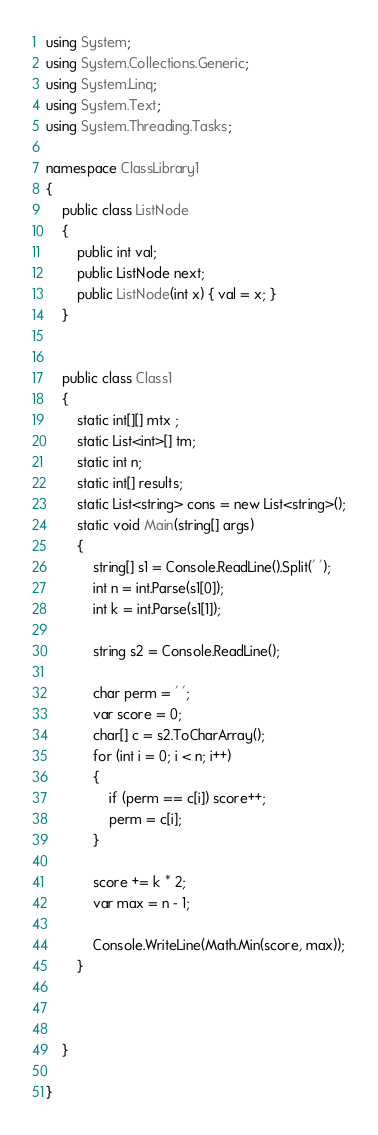<code> <loc_0><loc_0><loc_500><loc_500><_C#_>using System;
using System.Collections.Generic;
using System.Linq;
using System.Text;
using System.Threading.Tasks;

namespace ClassLibrary1
{
    public class ListNode
    {
        public int val;
        public ListNode next;
        public ListNode(int x) { val = x; }
    }


    public class Class1
    {
        static int[][] mtx ;
        static List<int>[] tm;
        static int n;
        static int[] results;
        static List<string> cons = new List<string>();
        static void Main(string[] args)
        {
            string[] s1 = Console.ReadLine().Split(' ');
            int n = int.Parse(s1[0]);
            int k = int.Parse(s1[1]);

            string s2 = Console.ReadLine();

            char perm = ' ';
            var score = 0;
            char[] c = s2.ToCharArray();
            for (int i = 0; i < n; i++)
            {
                if (perm == c[i]) score++;
                perm = c[i];
            }

            score += k * 2;
            var max = n - 1;

            Console.WriteLine(Math.Min(score, max));
        }

 

    }

}</code> 